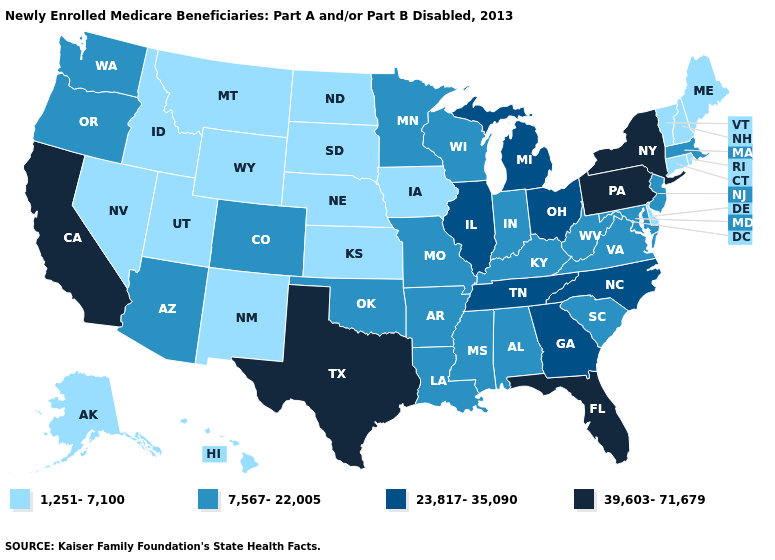What is the value of Wyoming?
Answer briefly. 1,251-7,100. Does Hawaii have the same value as Illinois?
Give a very brief answer. No. Does the first symbol in the legend represent the smallest category?
Answer briefly. Yes. Does Indiana have the lowest value in the USA?
Concise answer only. No. How many symbols are there in the legend?
Quick response, please. 4. Which states have the lowest value in the West?
Give a very brief answer. Alaska, Hawaii, Idaho, Montana, Nevada, New Mexico, Utah, Wyoming. Which states have the highest value in the USA?
Keep it brief. California, Florida, New York, Pennsylvania, Texas. What is the value of Montana?
Concise answer only. 1,251-7,100. Which states have the lowest value in the USA?
Answer briefly. Alaska, Connecticut, Delaware, Hawaii, Idaho, Iowa, Kansas, Maine, Montana, Nebraska, Nevada, New Hampshire, New Mexico, North Dakota, Rhode Island, South Dakota, Utah, Vermont, Wyoming. Does the first symbol in the legend represent the smallest category?
Short answer required. Yes. Among the states that border Missouri , does Tennessee have the highest value?
Short answer required. Yes. What is the value of Utah?
Answer briefly. 1,251-7,100. Which states have the lowest value in the South?
Be succinct. Delaware. What is the value of Maryland?
Give a very brief answer. 7,567-22,005. Is the legend a continuous bar?
Answer briefly. No. 